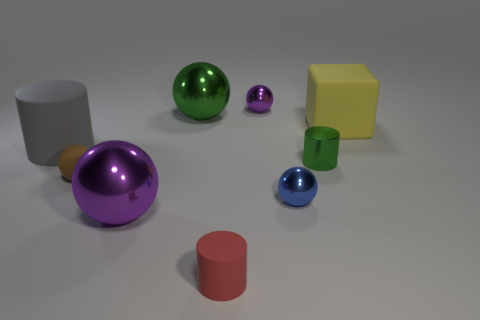Subtract all green spheres. How many spheres are left? 4 Subtract all tiny brown balls. How many balls are left? 4 Subtract all cyan spheres. Subtract all brown cylinders. How many spheres are left? 5 Subtract all cubes. How many objects are left? 8 Add 7 purple objects. How many purple objects exist? 9 Subtract 0 purple cylinders. How many objects are left? 9 Subtract all blocks. Subtract all tiny matte cylinders. How many objects are left? 7 Add 1 small purple objects. How many small purple objects are left? 2 